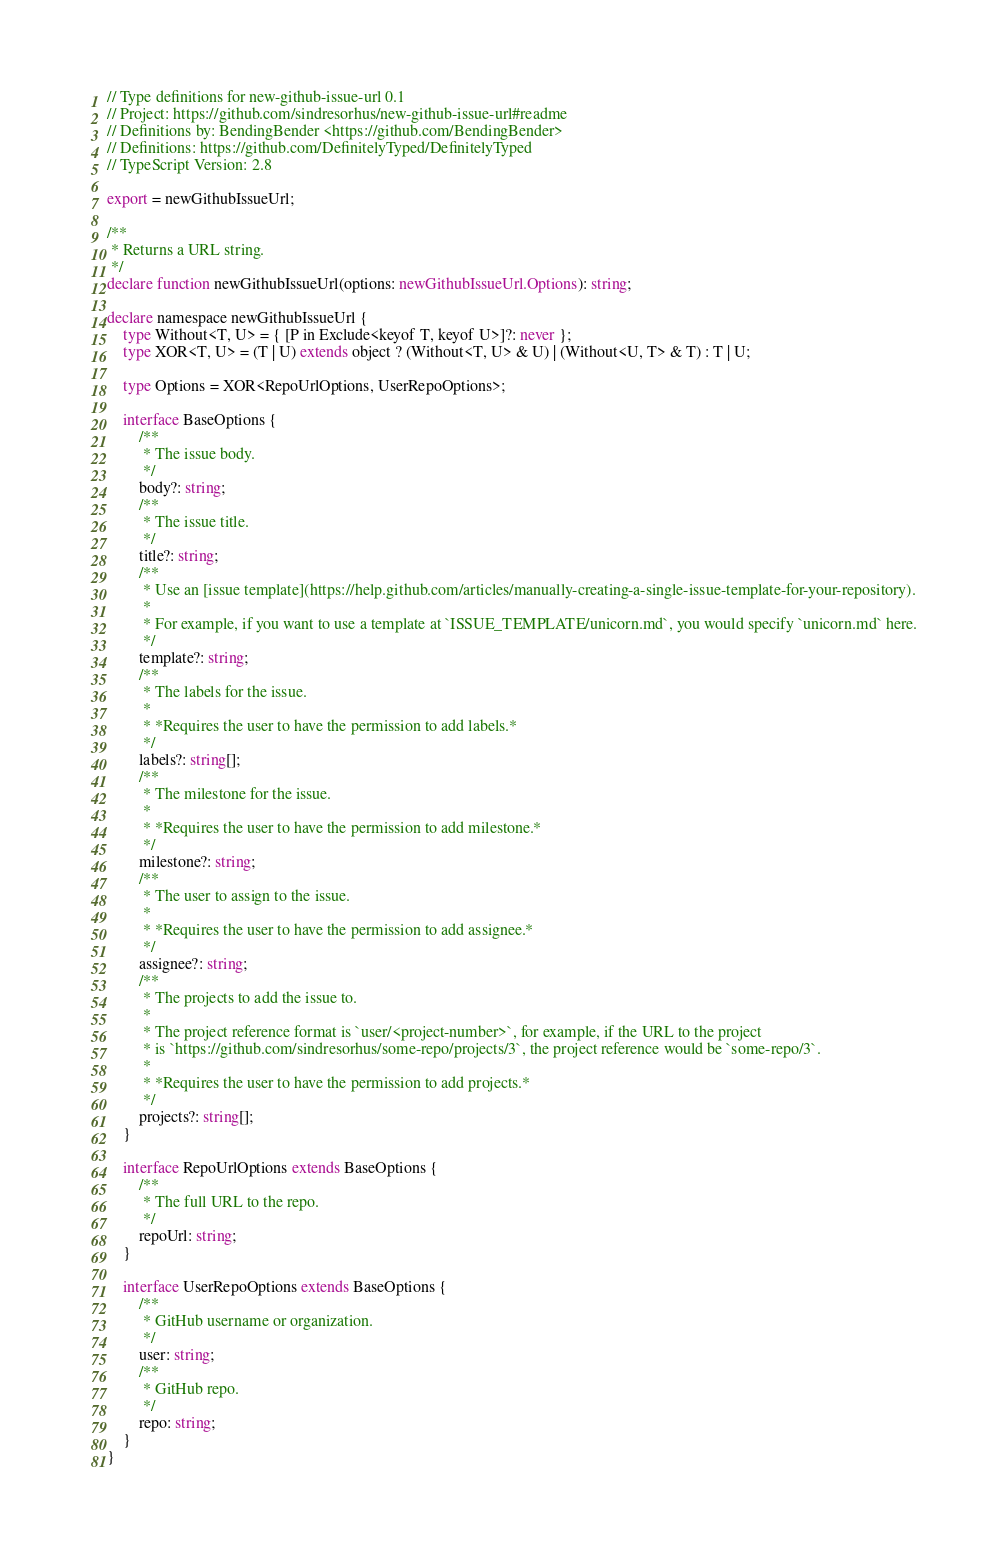Convert code to text. <code><loc_0><loc_0><loc_500><loc_500><_TypeScript_>// Type definitions for new-github-issue-url 0.1
// Project: https://github.com/sindresorhus/new-github-issue-url#readme
// Definitions by: BendingBender <https://github.com/BendingBender>
// Definitions: https://github.com/DefinitelyTyped/DefinitelyTyped
// TypeScript Version: 2.8

export = newGithubIssueUrl;

/**
 * Returns a URL string.
 */
declare function newGithubIssueUrl(options: newGithubIssueUrl.Options): string;

declare namespace newGithubIssueUrl {
    type Without<T, U> = { [P in Exclude<keyof T, keyof U>]?: never };
    type XOR<T, U> = (T | U) extends object ? (Without<T, U> & U) | (Without<U, T> & T) : T | U;

    type Options = XOR<RepoUrlOptions, UserRepoOptions>;

    interface BaseOptions {
        /**
         * The issue body.
         */
        body?: string;
        /**
         * The issue title.
         */
        title?: string;
        /**
         * Use an [issue template](https://help.github.com/articles/manually-creating-a-single-issue-template-for-your-repository).
         *
         * For example, if you want to use a template at `ISSUE_TEMPLATE/unicorn.md`, you would specify `unicorn.md` here.
         */
        template?: string;
        /**
         * The labels for the issue.
         *
         * *Requires the user to have the permission to add labels.*
         */
        labels?: string[];
        /**
         * The milestone for the issue.
         *
         * *Requires the user to have the permission to add milestone.*
         */
        milestone?: string;
        /**
         * The user to assign to the issue.
         *
         * *Requires the user to have the permission to add assignee.*
         */
        assignee?: string;
        /**
         * The projects to add the issue to.
         *
         * The project reference format is `user/<project-number>`, for example, if the URL to the project
         * is `https://github.com/sindresorhus/some-repo/projects/3`, the project reference would be `some-repo/3`.
         *
         * *Requires the user to have the permission to add projects.*
         */
        projects?: string[];
    }

    interface RepoUrlOptions extends BaseOptions {
        /**
         * The full URL to the repo.
         */
        repoUrl: string;
    }

    interface UserRepoOptions extends BaseOptions {
        /**
         * GitHub username or organization.
         */
        user: string;
        /**
         * GitHub repo.
         */
        repo: string;
    }
}
</code> 